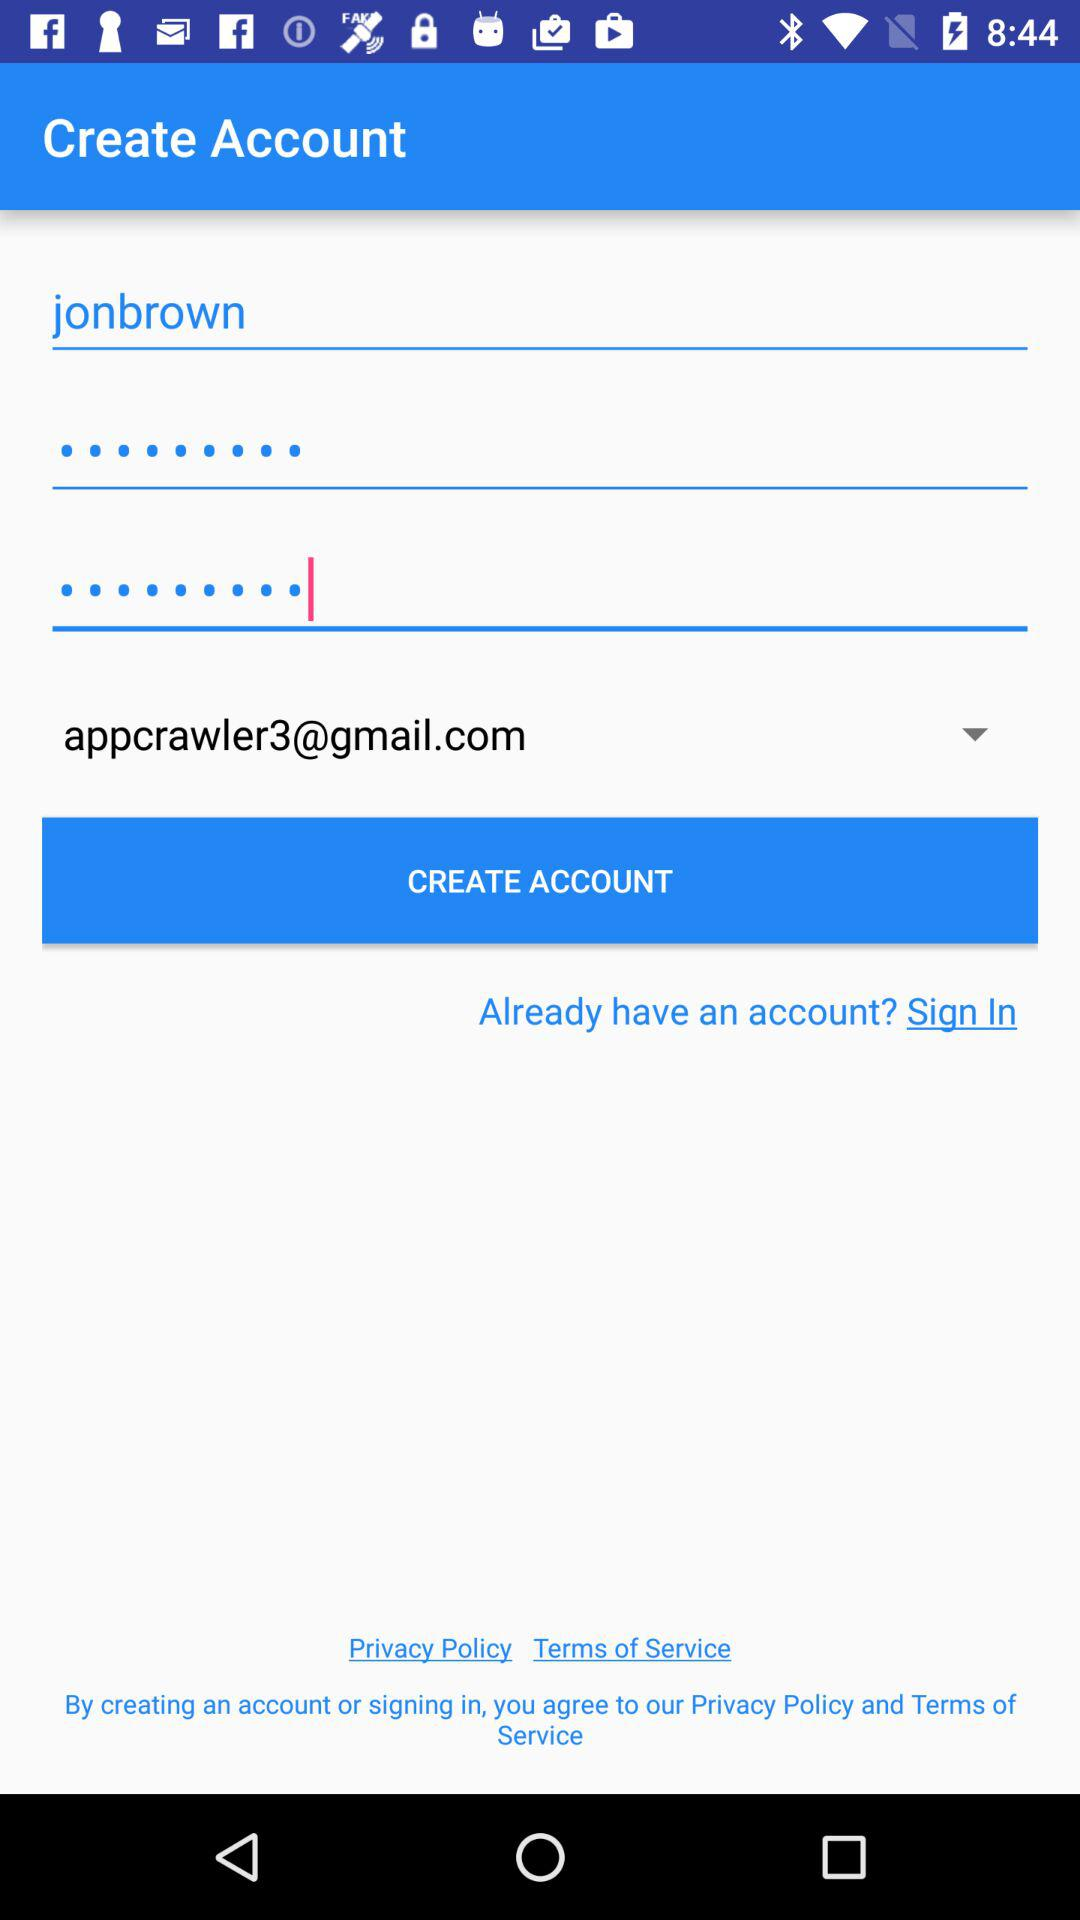What is the email address? The email address is appcrawler3@gmail.com. 